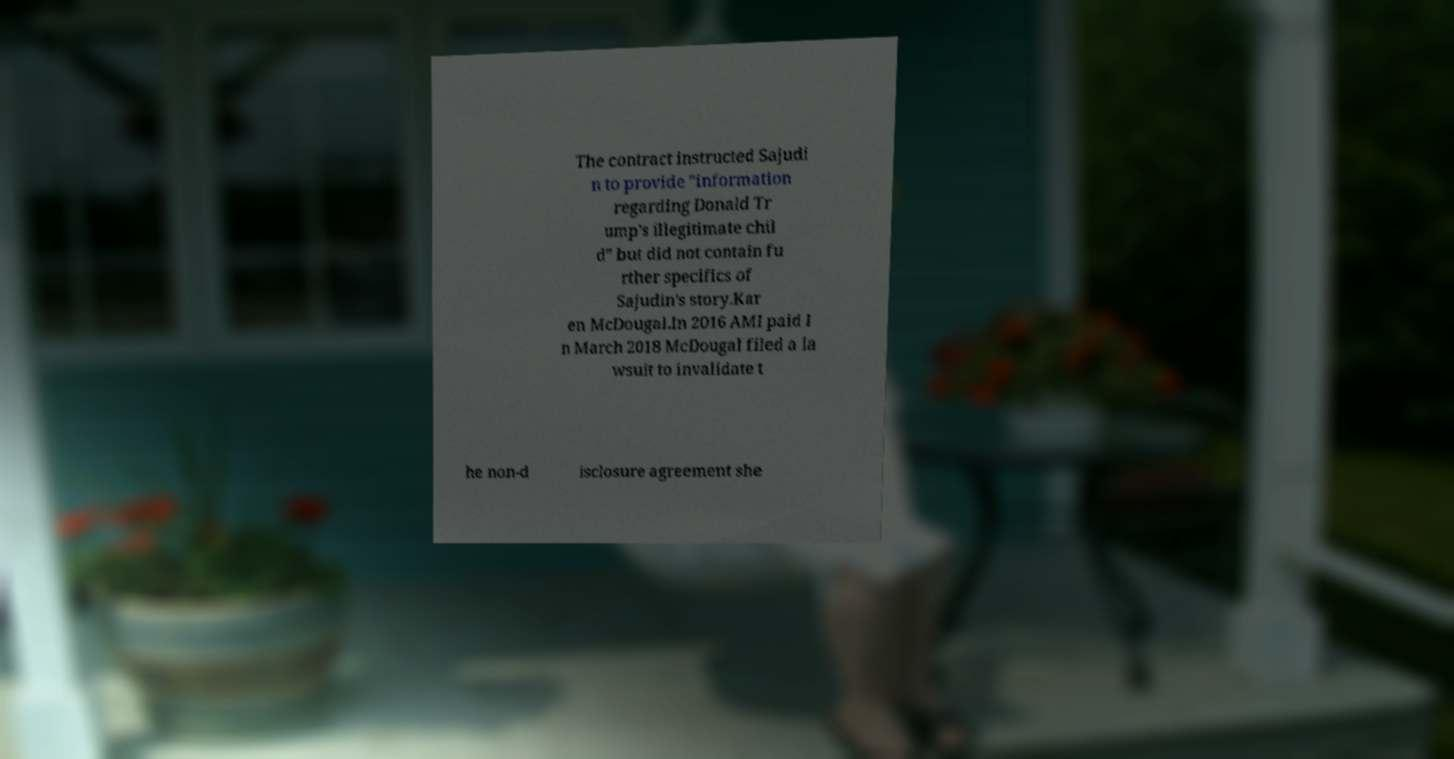There's text embedded in this image that I need extracted. Can you transcribe it verbatim? The contract instructed Sajudi n to provide "information regarding Donald Tr ump's illegitimate chil d" but did not contain fu rther specifics of Sajudin's story.Kar en McDougal.In 2016 AMI paid I n March 2018 McDougal filed a la wsuit to invalidate t he non-d isclosure agreement she 